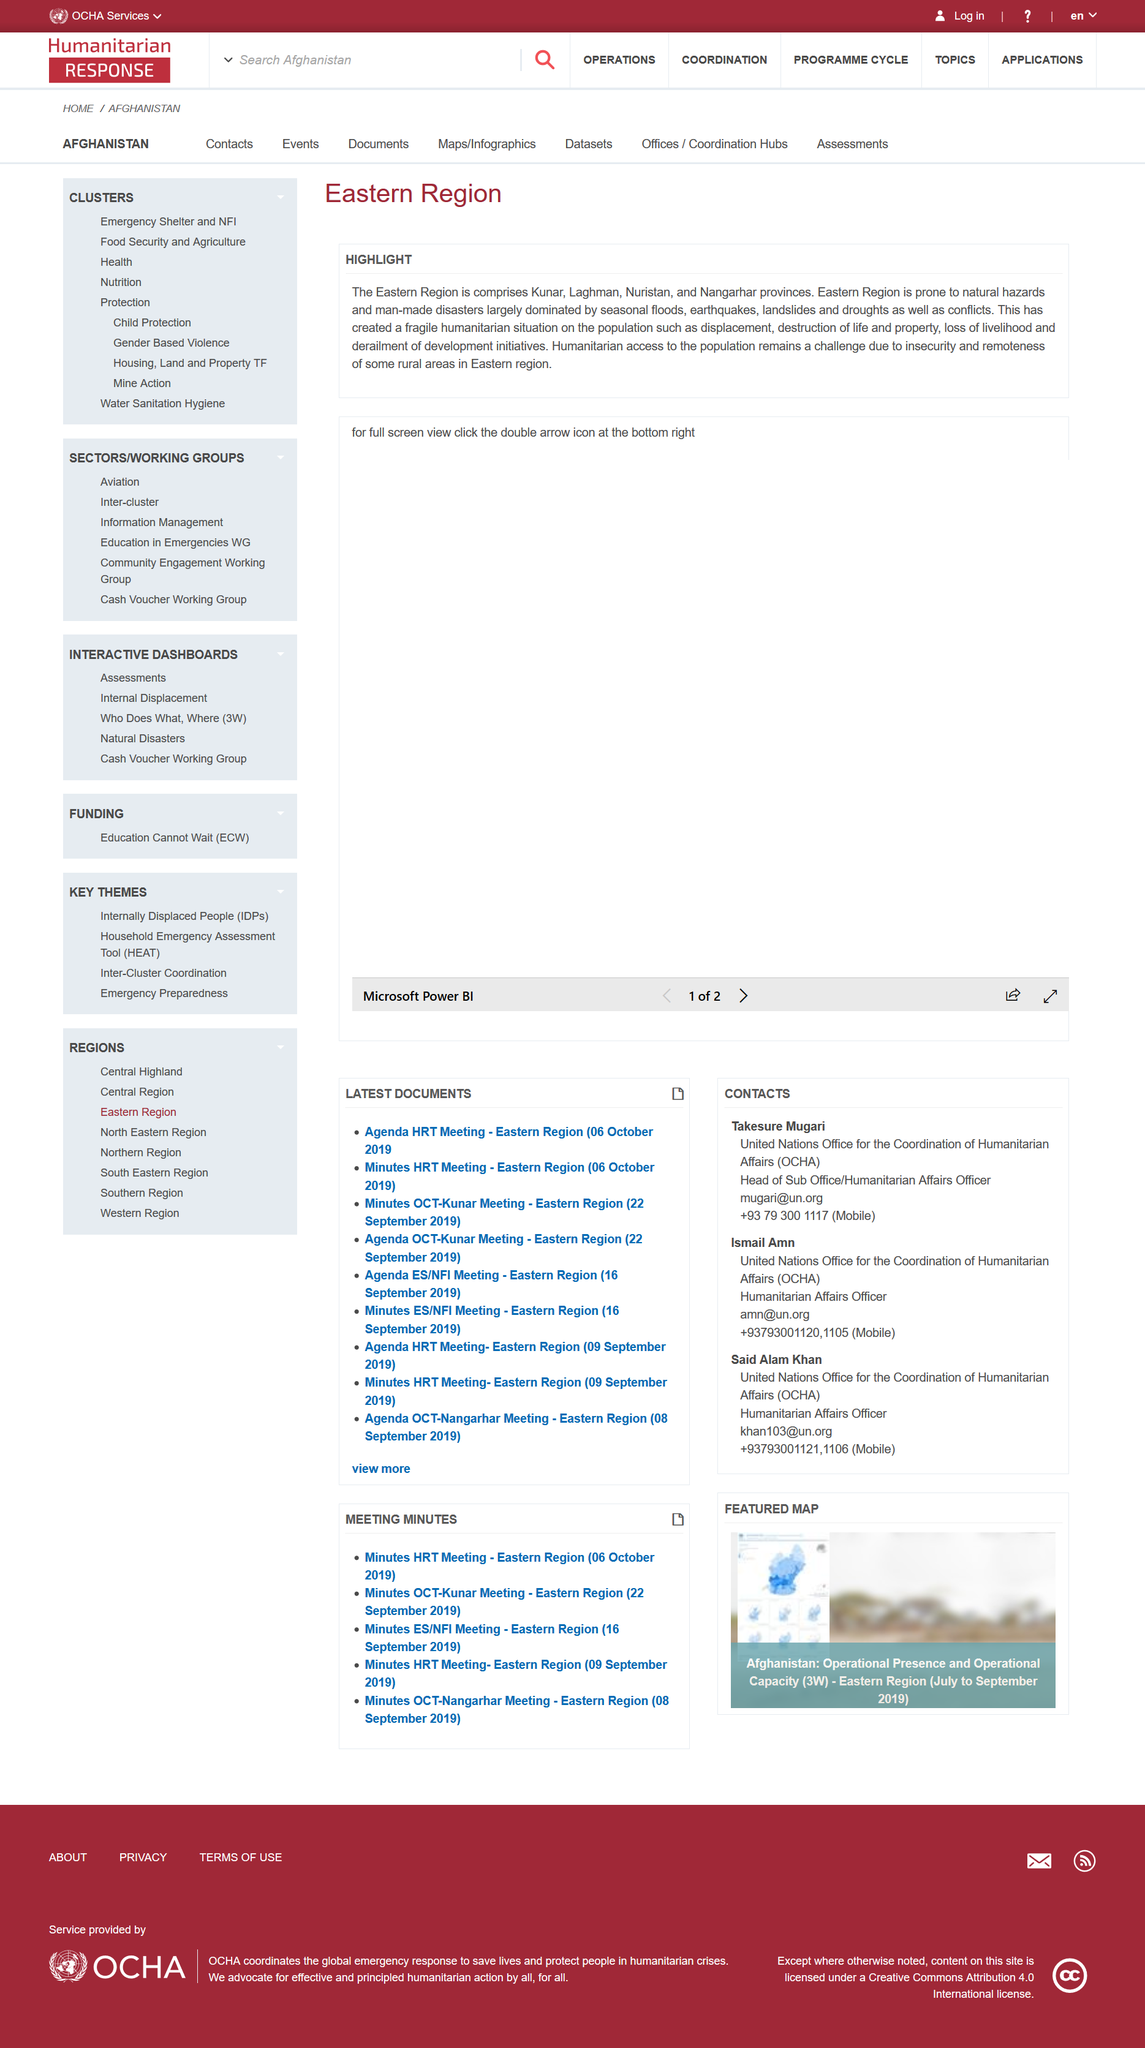Highlight a few significant elements in this photo. The Eastern Region is more susceptible to man-made disasters rather than natural disasters. The Eastern Region comprises four provinces. The Eastern Region is the subject of discussion in this snippet of information. 